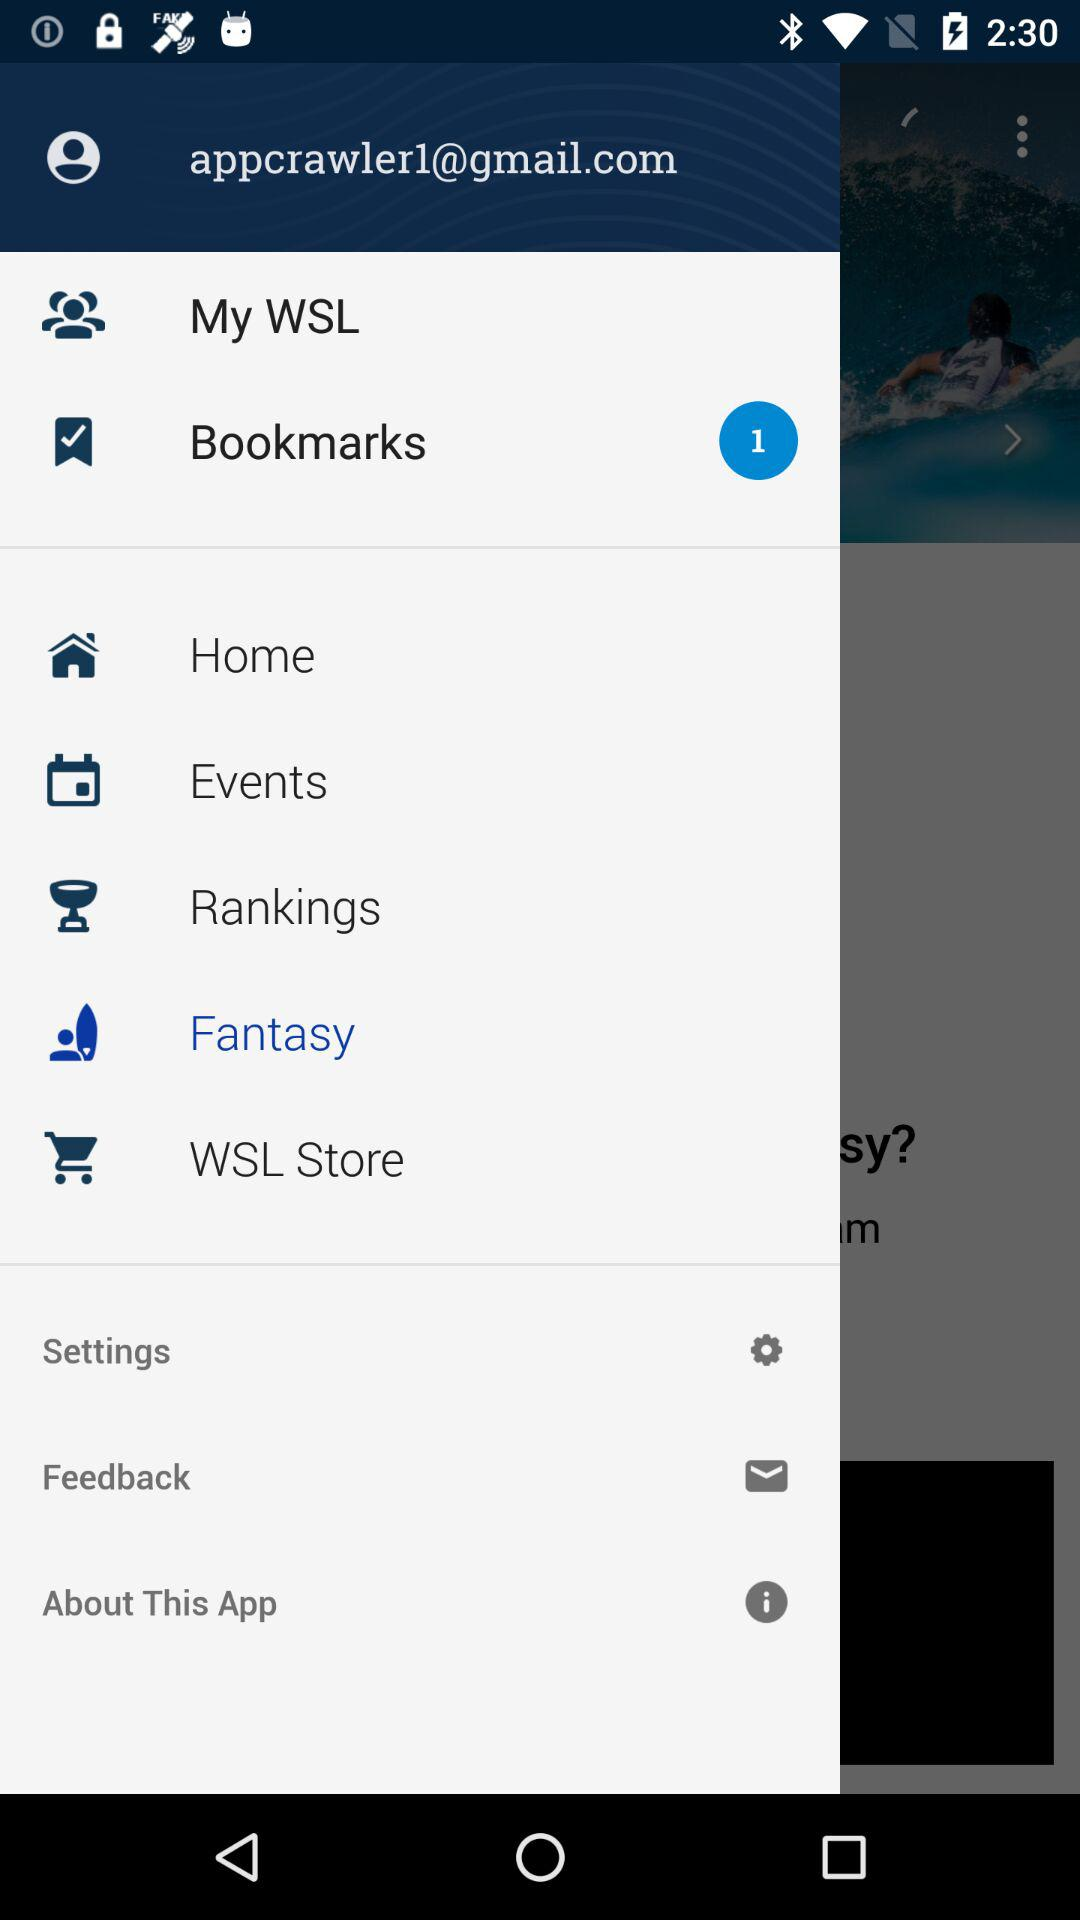What is the email address of the user? The email address of the user is appcrawler1@gmail.com. 